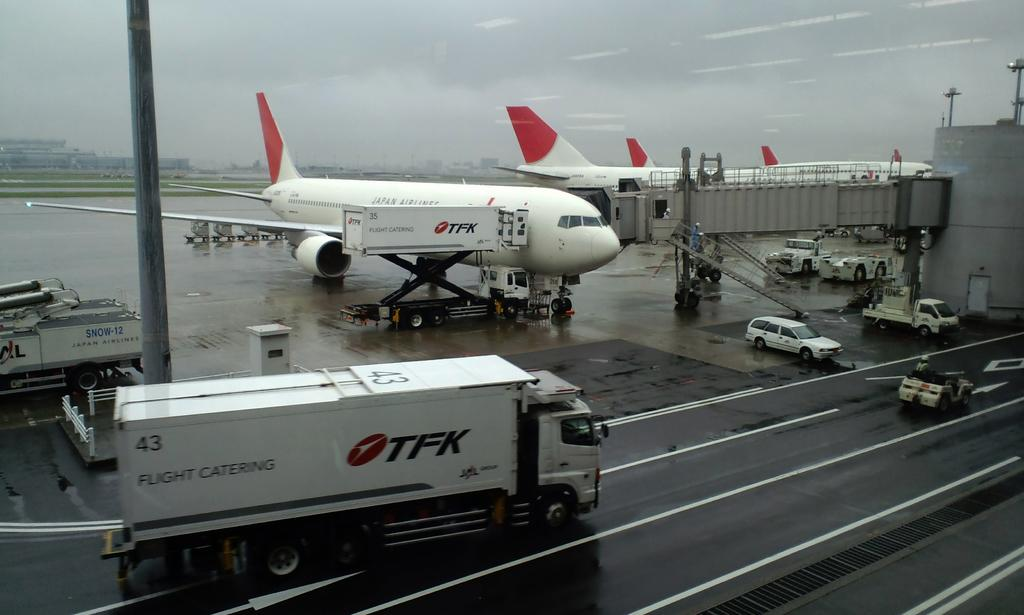<image>
Summarize the visual content of the image. a truck that says 'tfk' on the side of it 